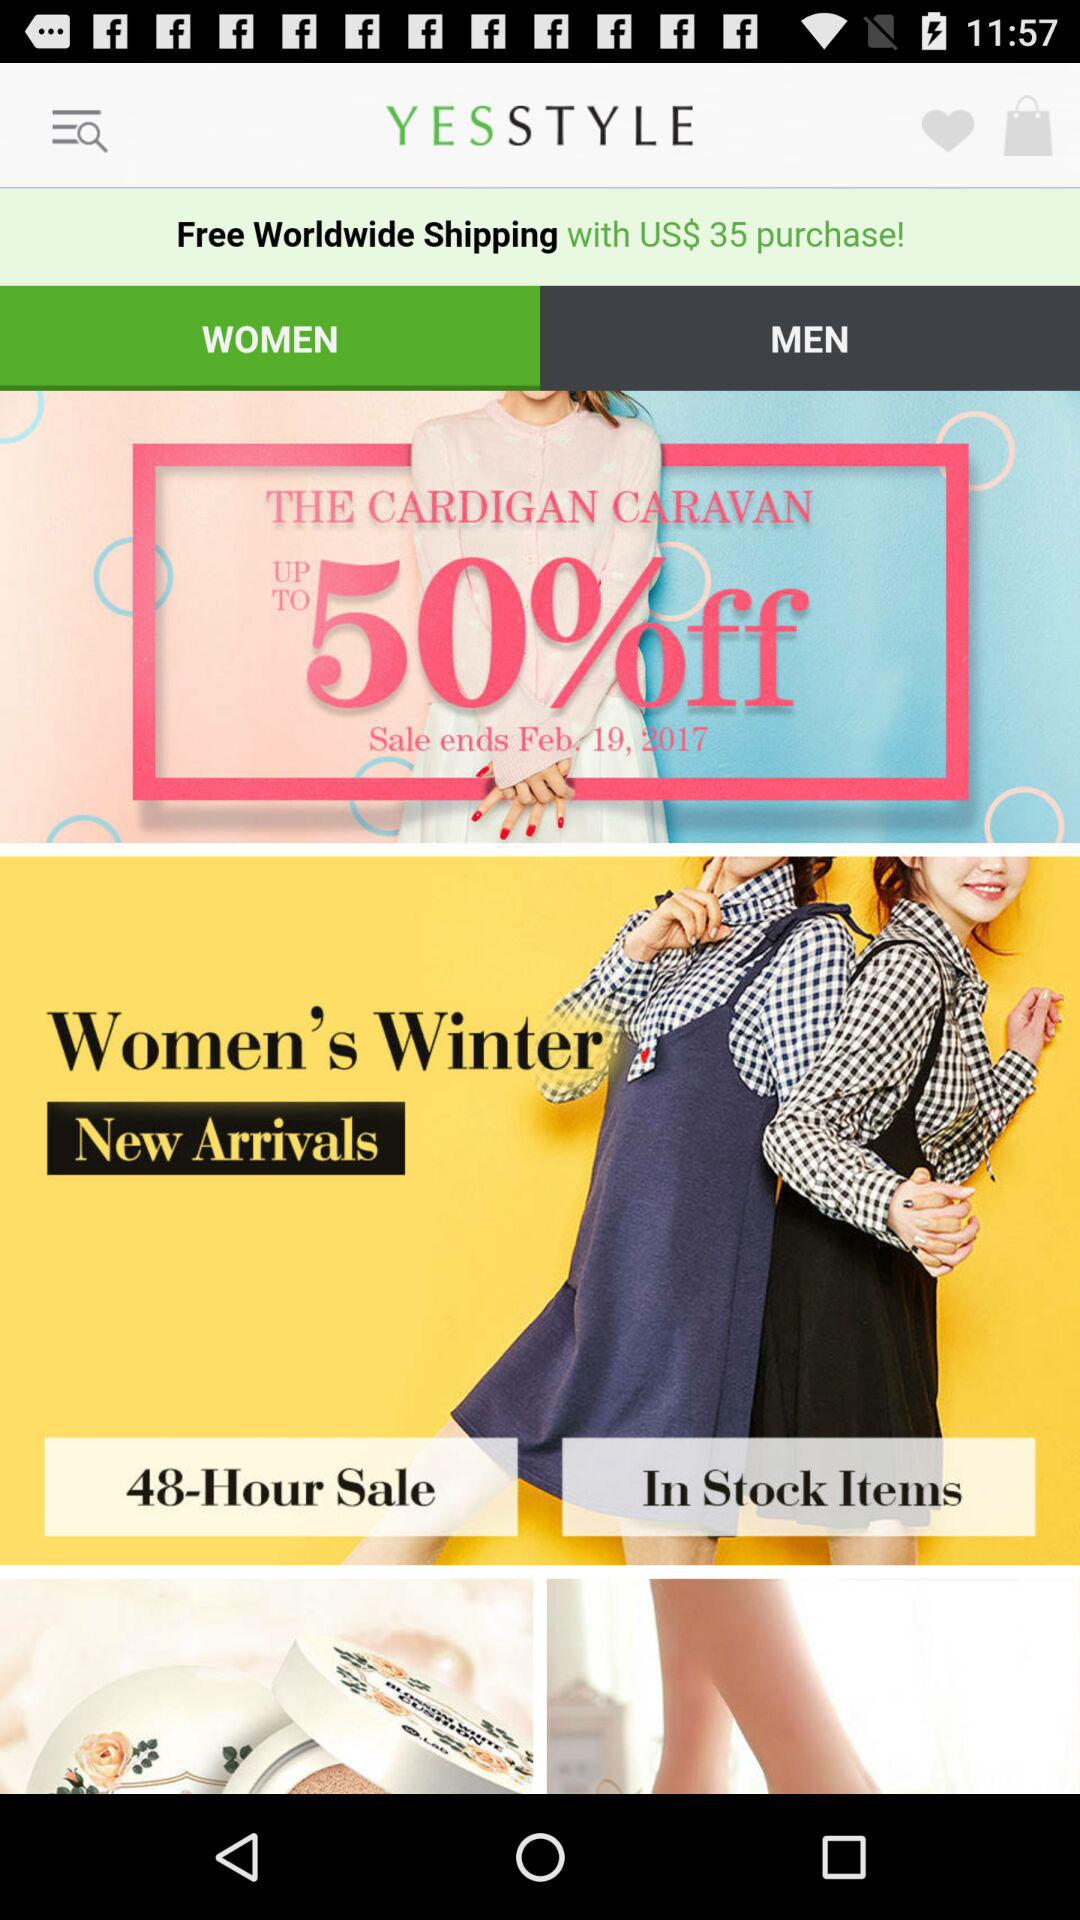What is the time duration of the sale? The time duration of the sale is 48 hours. 